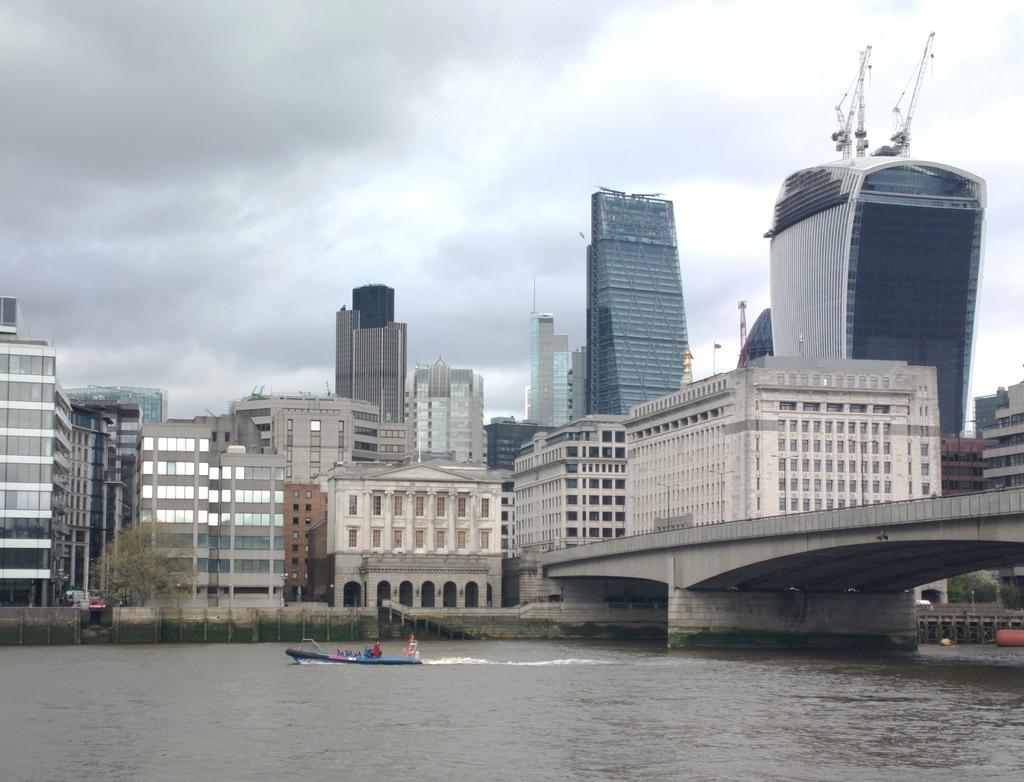How would you summarize this image in a sentence or two? Sky is cloudy. Here we can see buildings and windows. Above this water there is a bridge and boat. In-front of this building there is a tree. 